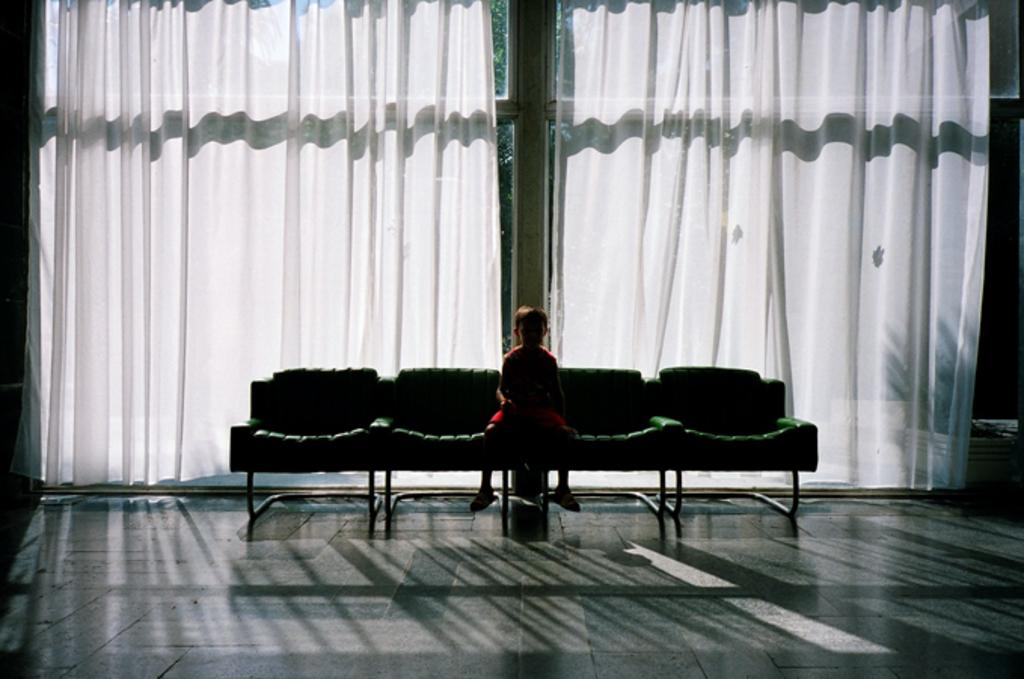What is the primary surface visible in the image? There is a floor in the image. How many chairs are on the floor? There are four chairs on the floor. What is the boy in the image doing? The boy is sitting on one of the chairs. What type of wall is visible in the background? There is a glass wall in the background. What type of window treatment is associated with the glass wall? There are two white curtains associated with the glass wall. What type of marble is the boy learning in the image? There is no marble or learning activity present in the image. The boy is simply sitting on a chair. 